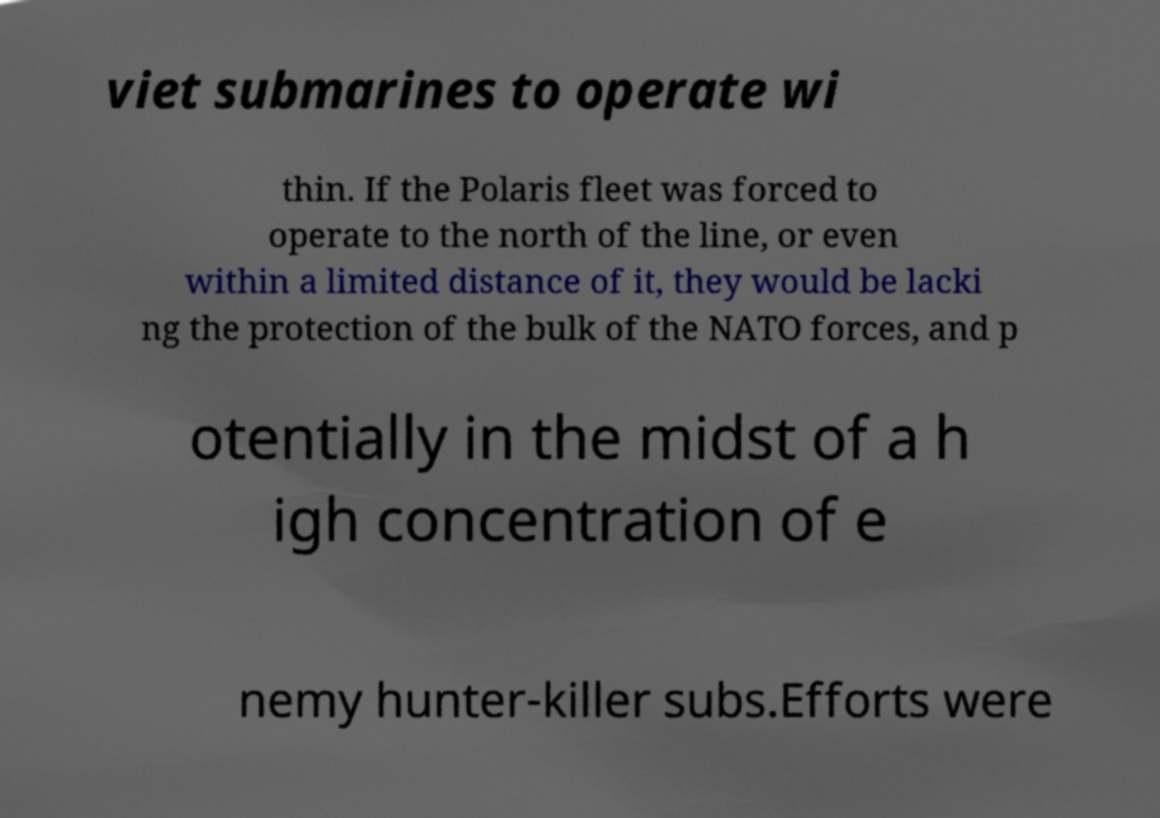What messages or text are displayed in this image? I need them in a readable, typed format. viet submarines to operate wi thin. If the Polaris fleet was forced to operate to the north of the line, or even within a limited distance of it, they would be lacki ng the protection of the bulk of the NATO forces, and p otentially in the midst of a h igh concentration of e nemy hunter-killer subs.Efforts were 